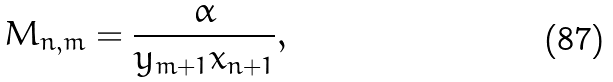Convert formula to latex. <formula><loc_0><loc_0><loc_500><loc_500>M _ { n , m } = \frac { \alpha } { y _ { m + 1 } x _ { n + 1 } } ,</formula> 